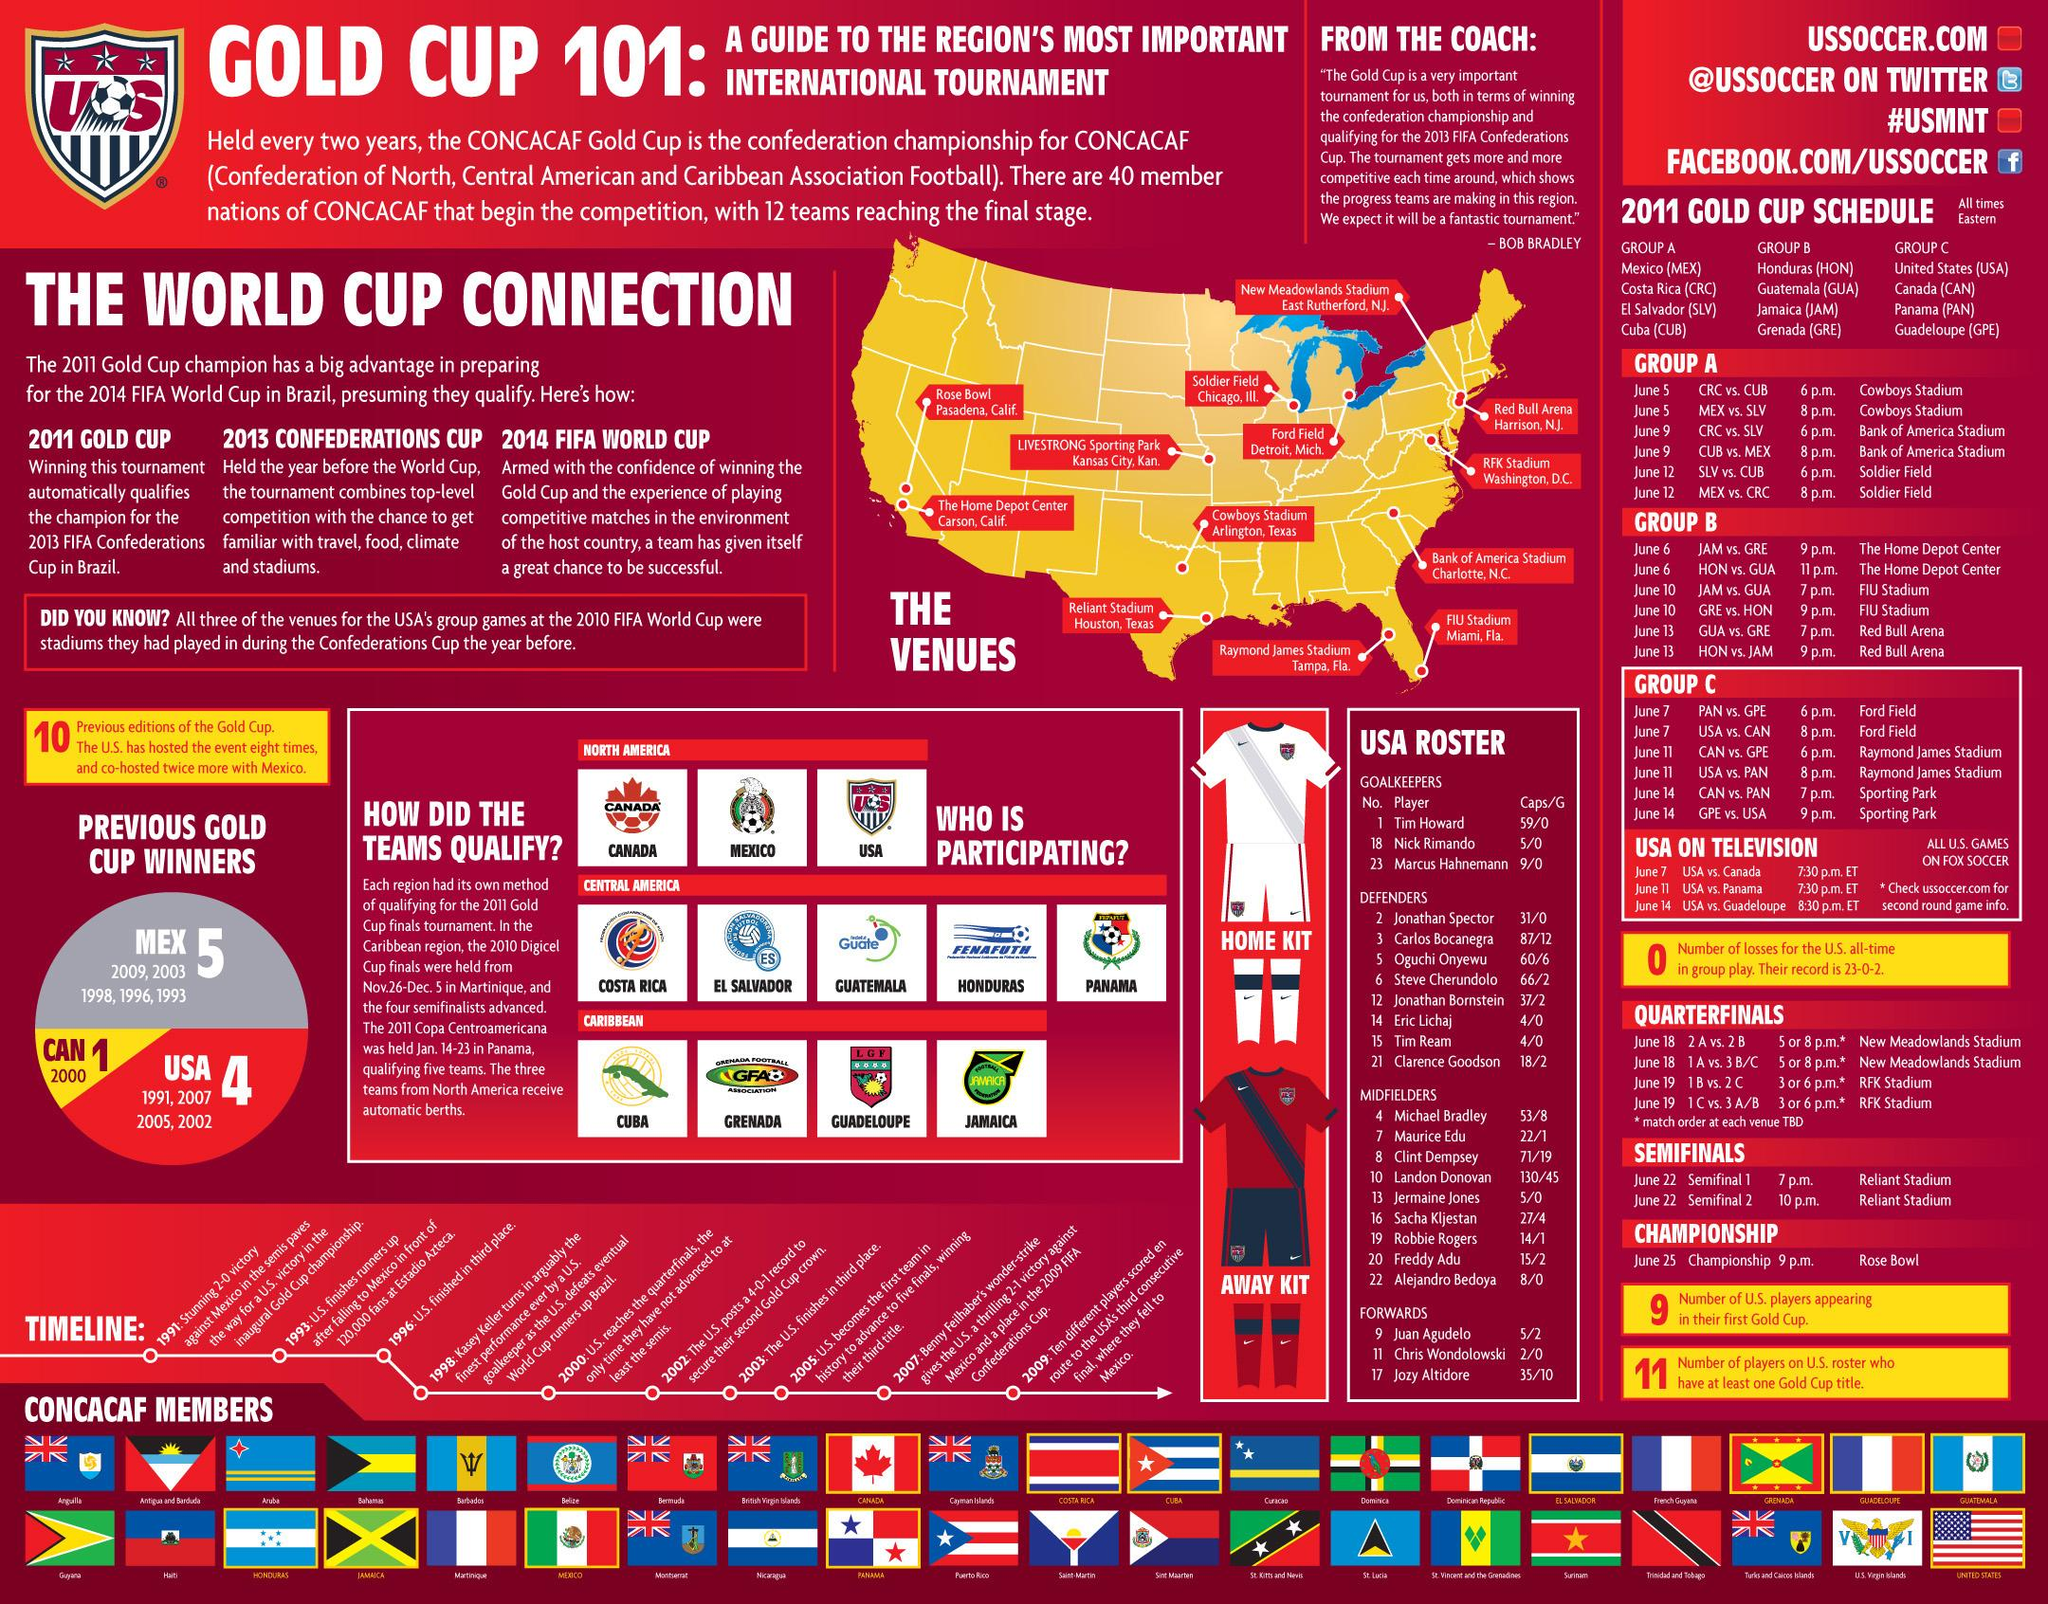Give some essential details in this illustration. There are 40 CONCACAF members displayed. 